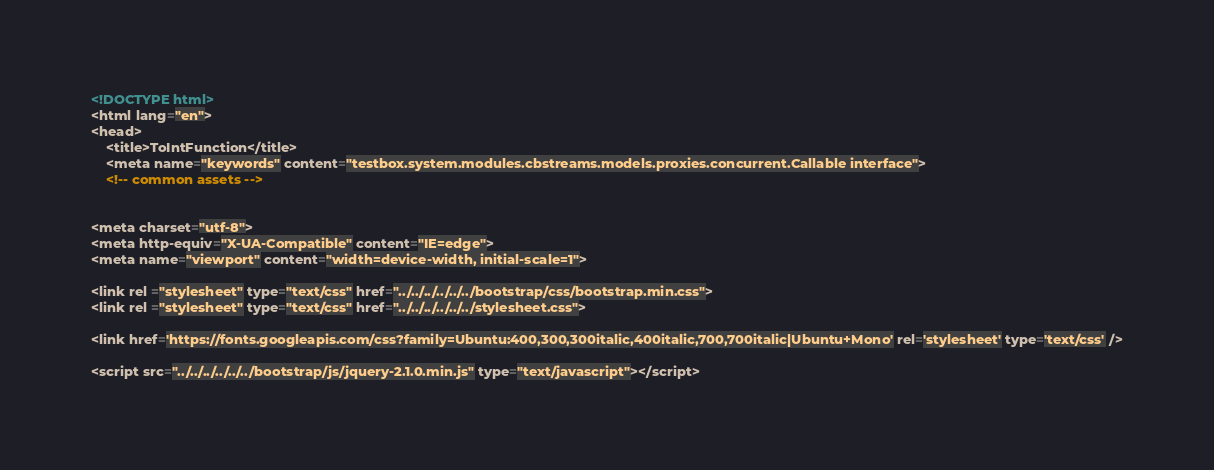<code> <loc_0><loc_0><loc_500><loc_500><_HTML_>

<!DOCTYPE html>
<html lang="en">
<head>
	<title>ToIntFunction</title>
	<meta name="keywords" content="testbox.system.modules.cbstreams.models.proxies.concurrent.Callable interface">
	<!-- common assets -->
	

<meta charset="utf-8">
<meta http-equiv="X-UA-Compatible" content="IE=edge">
<meta name="viewport" content="width=device-width, initial-scale=1">

<link rel ="stylesheet" type="text/css" href="../../../../../../bootstrap/css/bootstrap.min.css">
<link rel ="stylesheet" type="text/css" href="../../../../../../stylesheet.css">
	
<link href='https://fonts.googleapis.com/css?family=Ubuntu:400,300,300italic,400italic,700,700italic|Ubuntu+Mono' rel='stylesheet' type='text/css' />
	
<script src="../../../../../../bootstrap/js/jquery-2.1.0.min.js" type="text/javascript"></script></code> 